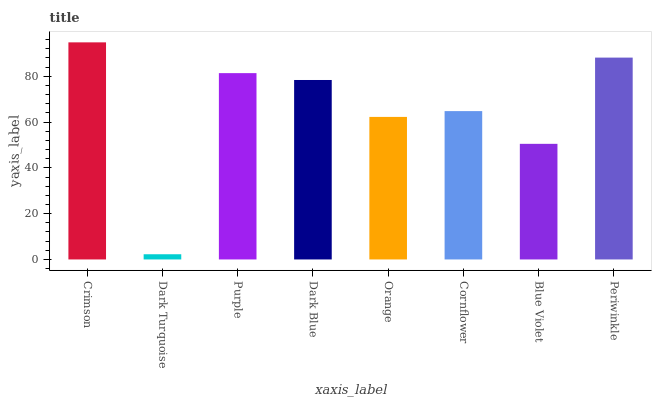Is Dark Turquoise the minimum?
Answer yes or no. Yes. Is Crimson the maximum?
Answer yes or no. Yes. Is Purple the minimum?
Answer yes or no. No. Is Purple the maximum?
Answer yes or no. No. Is Purple greater than Dark Turquoise?
Answer yes or no. Yes. Is Dark Turquoise less than Purple?
Answer yes or no. Yes. Is Dark Turquoise greater than Purple?
Answer yes or no. No. Is Purple less than Dark Turquoise?
Answer yes or no. No. Is Dark Blue the high median?
Answer yes or no. Yes. Is Cornflower the low median?
Answer yes or no. Yes. Is Periwinkle the high median?
Answer yes or no. No. Is Orange the low median?
Answer yes or no. No. 